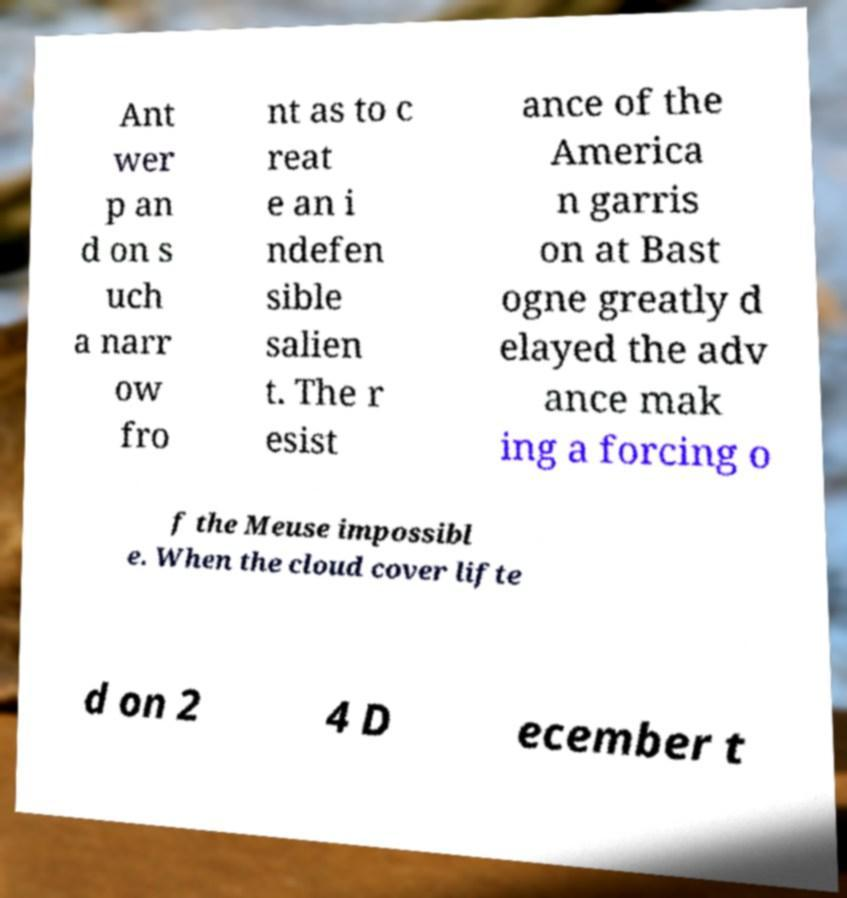Could you extract and type out the text from this image? Ant wer p an d on s uch a narr ow fro nt as to c reat e an i ndefen sible salien t. The r esist ance of the America n garris on at Bast ogne greatly d elayed the adv ance mak ing a forcing o f the Meuse impossibl e. When the cloud cover lifte d on 2 4 D ecember t 